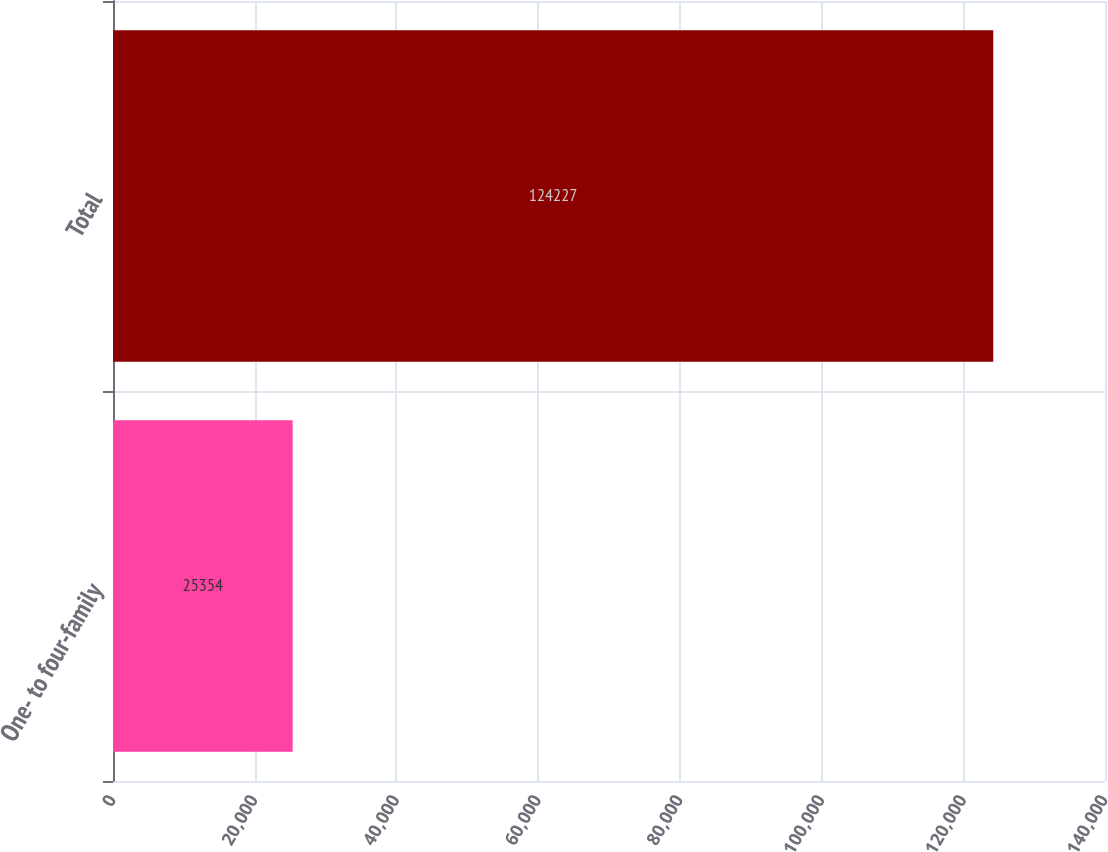Convert chart to OTSL. <chart><loc_0><loc_0><loc_500><loc_500><bar_chart><fcel>One- to four-family<fcel>Total<nl><fcel>25354<fcel>124227<nl></chart> 